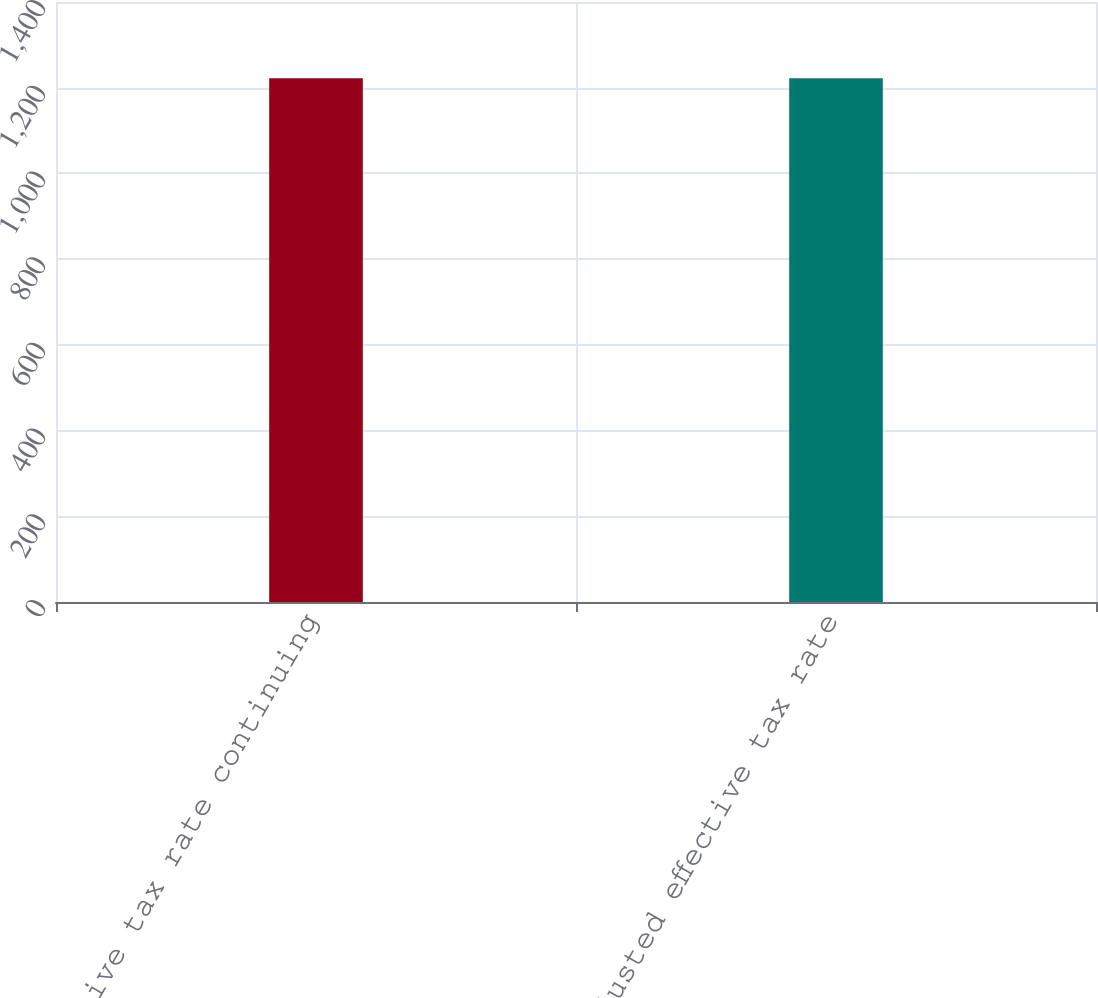Convert chart. <chart><loc_0><loc_0><loc_500><loc_500><bar_chart><fcel>Effective tax rate continuing<fcel>Adjusted effective tax rate<nl><fcel>1222<fcel>1222.1<nl></chart> 